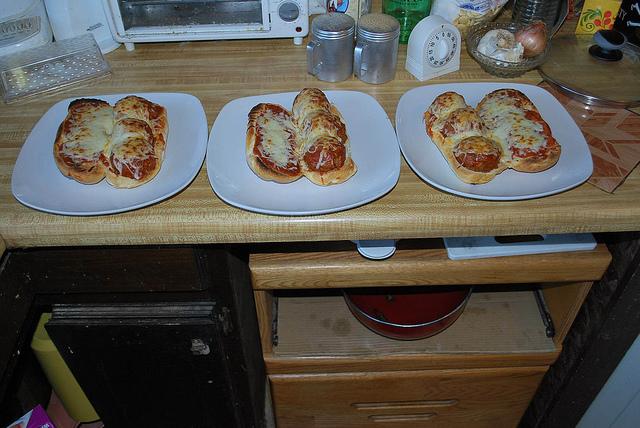Is this a bakery?
Answer briefly. No. Is the food healthy?
Concise answer only. No. Could these be desserts?
Be succinct. No. Is the butter out?
Give a very brief answer. Yes. Where is this taken?
Be succinct. Kitchen. What color are the plates?
Answer briefly. White. Is this food cooked?
Write a very short answer. Yes. How many plates have food?
Concise answer only. 3. Could a vegetarian eat these food items?
Short answer required. No. 